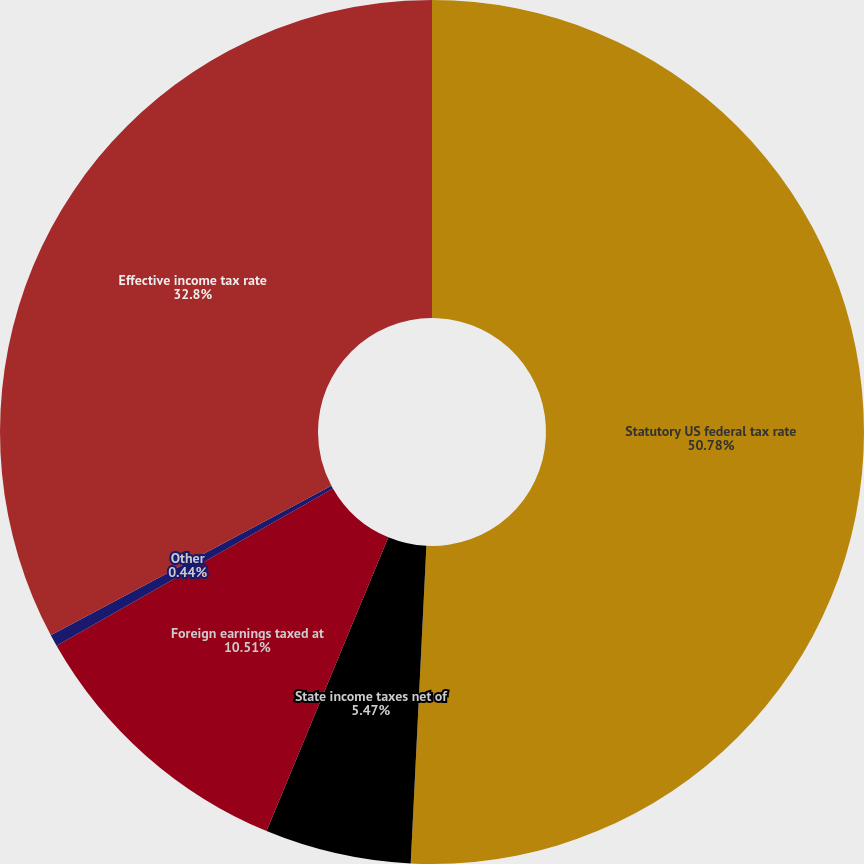Convert chart. <chart><loc_0><loc_0><loc_500><loc_500><pie_chart><fcel>Statutory US federal tax rate<fcel>State income taxes net of<fcel>Foreign earnings taxed at<fcel>Other<fcel>Effective income tax rate<nl><fcel>50.79%<fcel>5.47%<fcel>10.51%<fcel>0.44%<fcel>32.8%<nl></chart> 